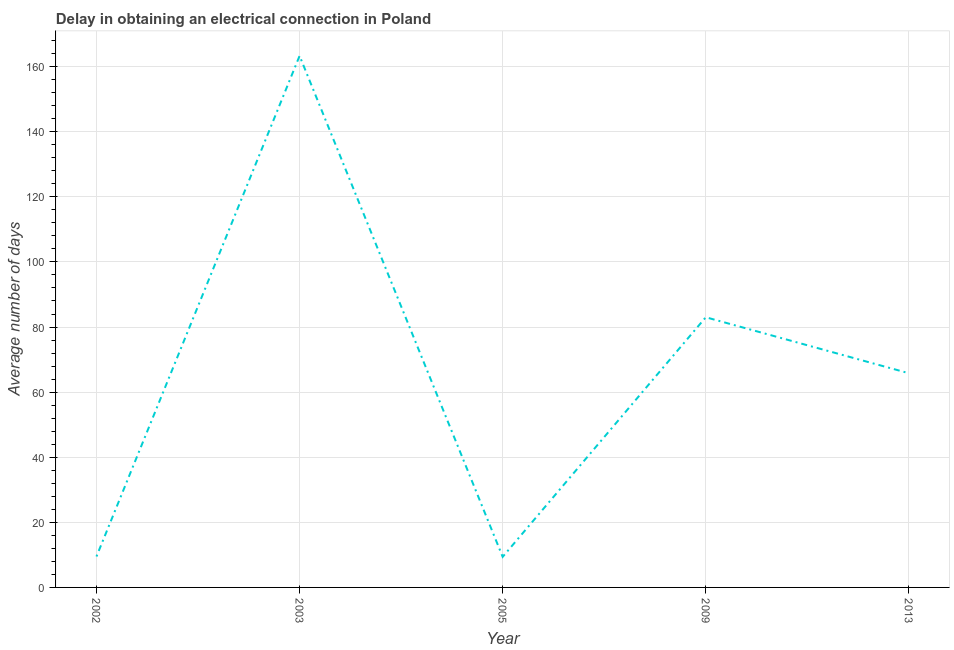What is the dalay in electrical connection in 2013?
Offer a terse response. 65.8. Across all years, what is the maximum dalay in electrical connection?
Offer a very short reply. 163.3. In which year was the dalay in electrical connection maximum?
Provide a short and direct response. 2003. What is the sum of the dalay in electrical connection?
Keep it short and to the point. 331. What is the difference between the dalay in electrical connection in 2005 and 2013?
Your answer should be compact. -56.4. What is the average dalay in electrical connection per year?
Give a very brief answer. 66.2. What is the median dalay in electrical connection?
Ensure brevity in your answer.  65.8. Do a majority of the years between 2009 and 2005 (inclusive) have dalay in electrical connection greater than 32 days?
Your answer should be compact. No. What is the ratio of the dalay in electrical connection in 2002 to that in 2009?
Offer a very short reply. 0.11. Is the dalay in electrical connection in 2003 less than that in 2005?
Provide a short and direct response. No. Is the difference between the dalay in electrical connection in 2003 and 2013 greater than the difference between any two years?
Your answer should be very brief. No. What is the difference between the highest and the second highest dalay in electrical connection?
Provide a short and direct response. 80.3. Is the sum of the dalay in electrical connection in 2002 and 2013 greater than the maximum dalay in electrical connection across all years?
Provide a succinct answer. No. What is the difference between the highest and the lowest dalay in electrical connection?
Ensure brevity in your answer.  153.9. How many years are there in the graph?
Give a very brief answer. 5. Does the graph contain any zero values?
Provide a short and direct response. No. What is the title of the graph?
Provide a short and direct response. Delay in obtaining an electrical connection in Poland. What is the label or title of the X-axis?
Ensure brevity in your answer.  Year. What is the label or title of the Y-axis?
Your answer should be very brief. Average number of days. What is the Average number of days in 2002?
Your answer should be compact. 9.5. What is the Average number of days in 2003?
Offer a very short reply. 163.3. What is the Average number of days in 2005?
Give a very brief answer. 9.4. What is the Average number of days of 2013?
Give a very brief answer. 65.8. What is the difference between the Average number of days in 2002 and 2003?
Offer a very short reply. -153.8. What is the difference between the Average number of days in 2002 and 2009?
Offer a terse response. -73.5. What is the difference between the Average number of days in 2002 and 2013?
Offer a terse response. -56.3. What is the difference between the Average number of days in 2003 and 2005?
Offer a very short reply. 153.9. What is the difference between the Average number of days in 2003 and 2009?
Provide a short and direct response. 80.3. What is the difference between the Average number of days in 2003 and 2013?
Your response must be concise. 97.5. What is the difference between the Average number of days in 2005 and 2009?
Offer a terse response. -73.6. What is the difference between the Average number of days in 2005 and 2013?
Your response must be concise. -56.4. What is the ratio of the Average number of days in 2002 to that in 2003?
Your response must be concise. 0.06. What is the ratio of the Average number of days in 2002 to that in 2009?
Ensure brevity in your answer.  0.11. What is the ratio of the Average number of days in 2002 to that in 2013?
Your response must be concise. 0.14. What is the ratio of the Average number of days in 2003 to that in 2005?
Ensure brevity in your answer.  17.37. What is the ratio of the Average number of days in 2003 to that in 2009?
Offer a very short reply. 1.97. What is the ratio of the Average number of days in 2003 to that in 2013?
Give a very brief answer. 2.48. What is the ratio of the Average number of days in 2005 to that in 2009?
Ensure brevity in your answer.  0.11. What is the ratio of the Average number of days in 2005 to that in 2013?
Provide a short and direct response. 0.14. What is the ratio of the Average number of days in 2009 to that in 2013?
Your answer should be very brief. 1.26. 